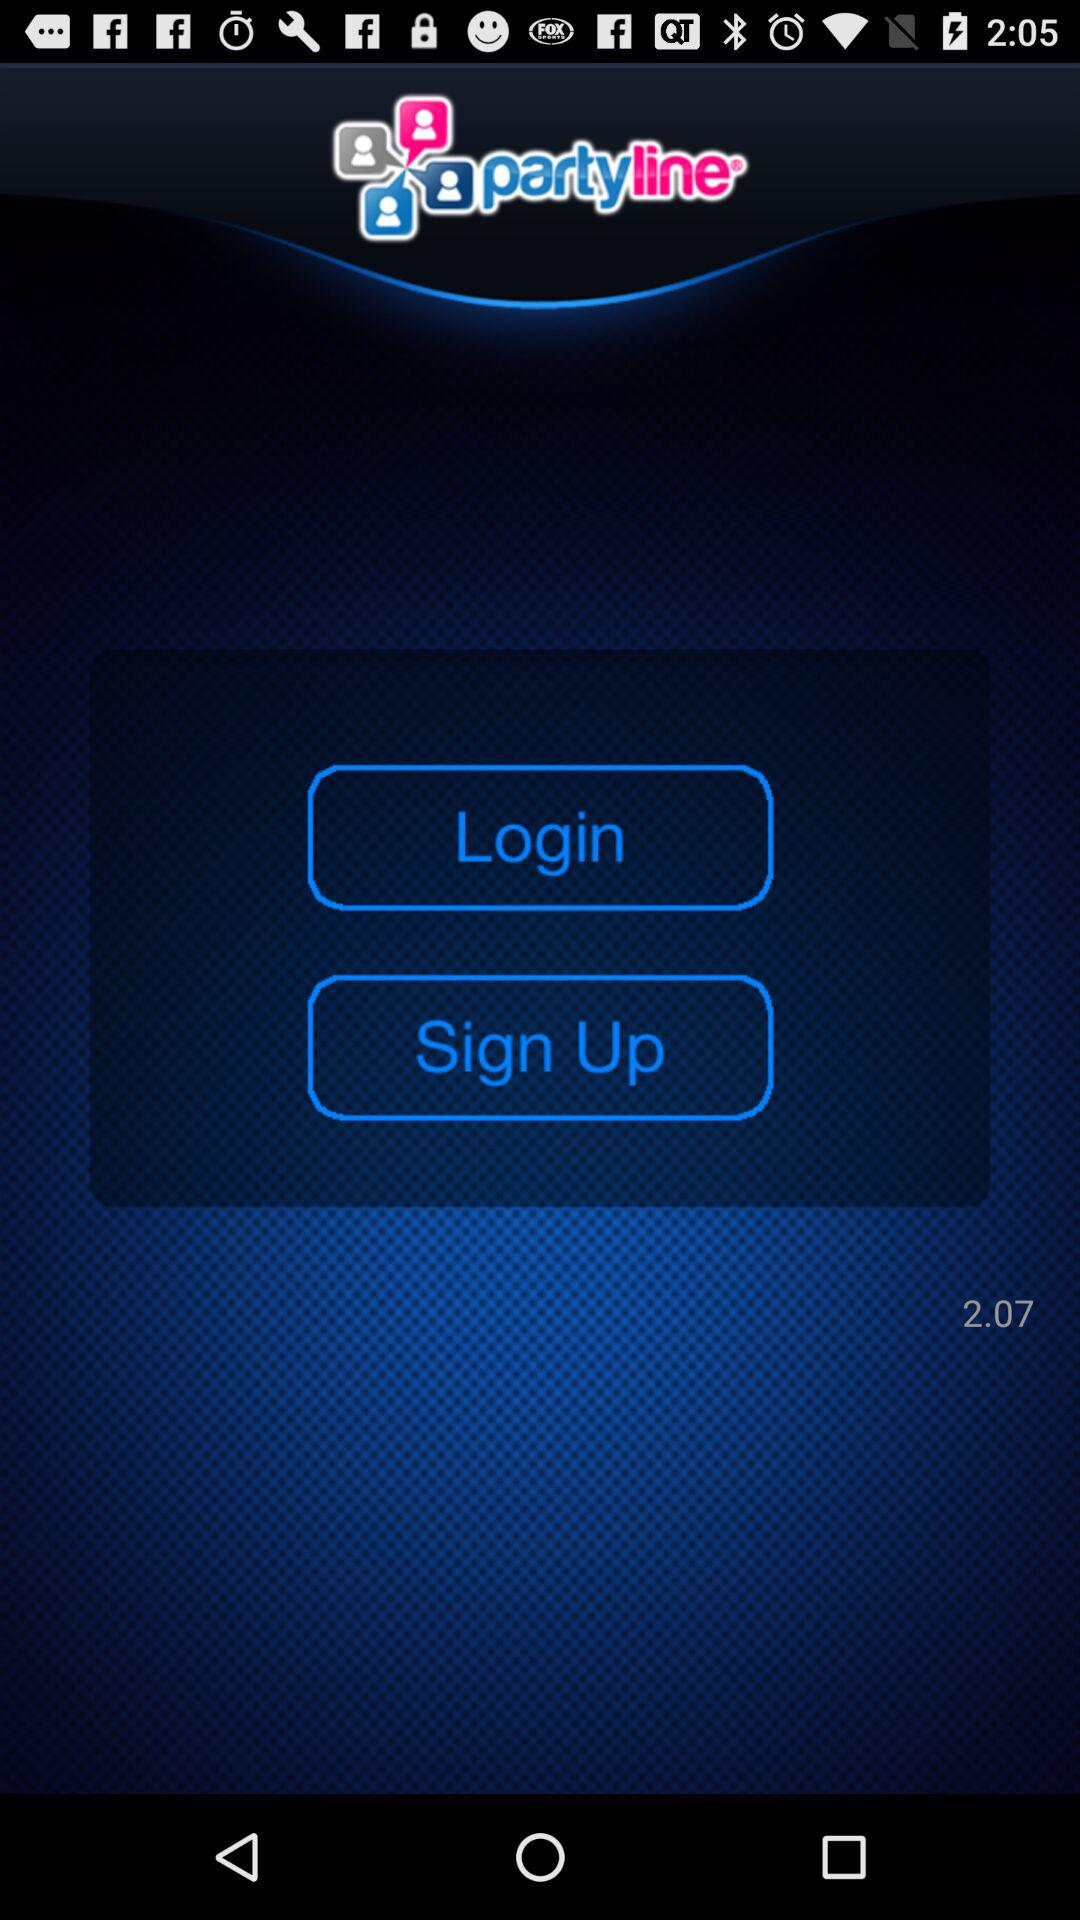What is the name of the application? The application name is "partyline". 